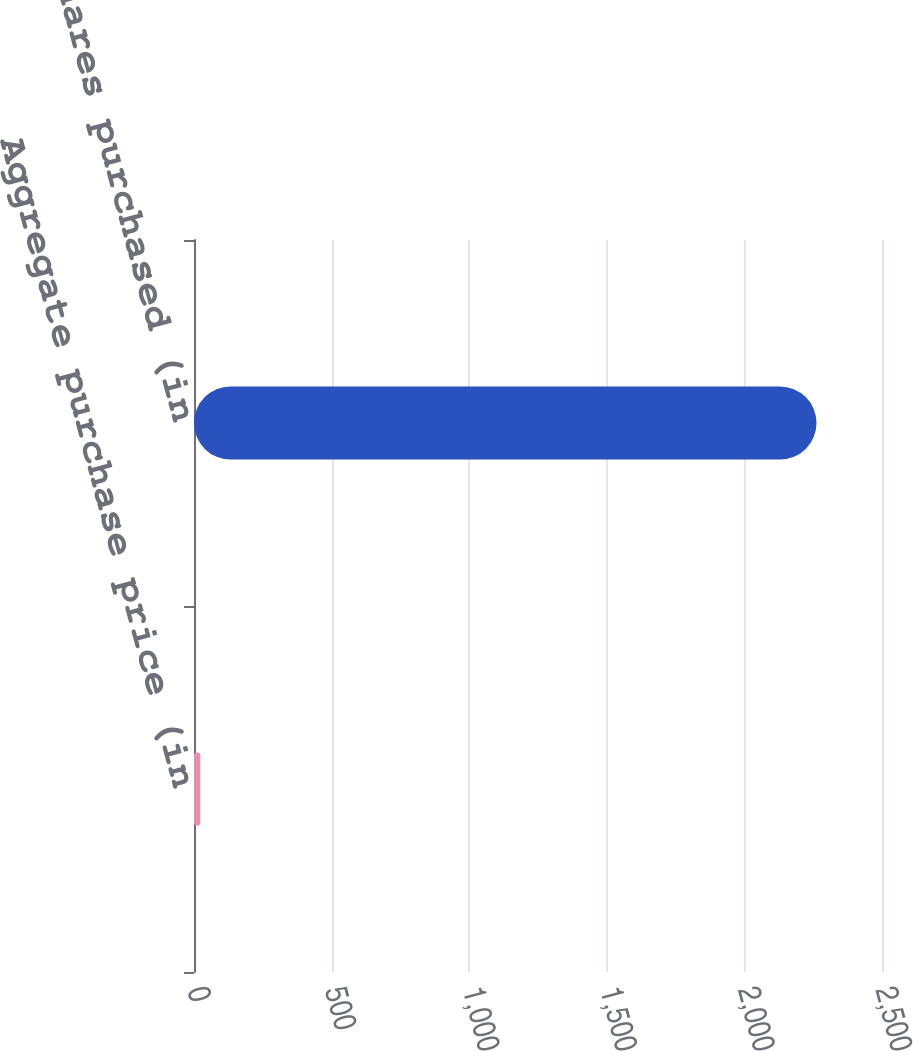<chart> <loc_0><loc_0><loc_500><loc_500><bar_chart><fcel>Aggregate purchase price (in<fcel>Shares purchased (in<nl><fcel>23<fcel>2262<nl></chart> 